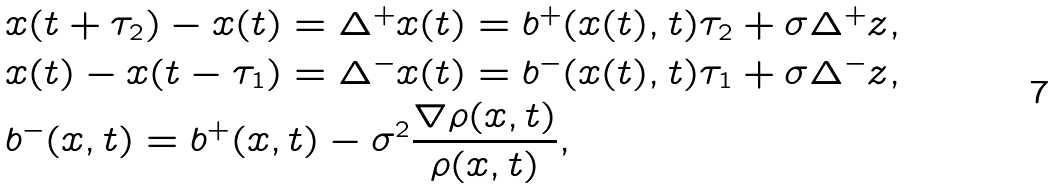<formula> <loc_0><loc_0><loc_500><loc_500>& x ( t + \tau _ { 2 } ) - x ( t ) = \Delta ^ { + } x ( t ) = b ^ { + } ( x ( t ) , t ) \tau _ { 2 } + \sigma \Delta ^ { + } z , \\ & x ( t ) - x ( t - \tau _ { 1 } ) = \Delta ^ { - } x ( t ) = b ^ { - } ( x ( t ) , t ) \tau _ { 1 } + \sigma \Delta ^ { - } z , \\ & b ^ { - } ( x , t ) = b ^ { + } ( x , t ) - \sigma ^ { 2 } \frac { \nabla \rho ( x , t ) } { \rho ( x , t ) } ,</formula> 